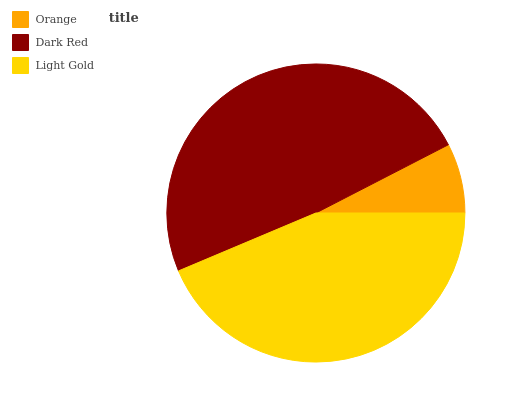Is Orange the minimum?
Answer yes or no. Yes. Is Dark Red the maximum?
Answer yes or no. Yes. Is Light Gold the minimum?
Answer yes or no. No. Is Light Gold the maximum?
Answer yes or no. No. Is Dark Red greater than Light Gold?
Answer yes or no. Yes. Is Light Gold less than Dark Red?
Answer yes or no. Yes. Is Light Gold greater than Dark Red?
Answer yes or no. No. Is Dark Red less than Light Gold?
Answer yes or no. No. Is Light Gold the high median?
Answer yes or no. Yes. Is Light Gold the low median?
Answer yes or no. Yes. Is Orange the high median?
Answer yes or no. No. Is Dark Red the low median?
Answer yes or no. No. 